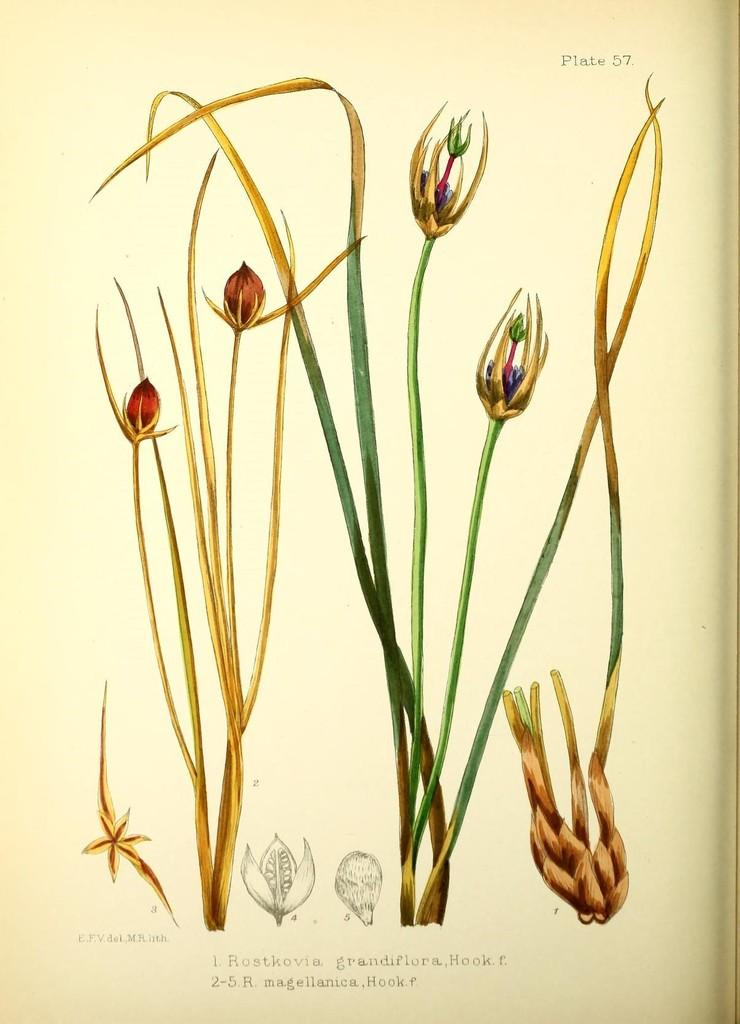What is the main subject of the image? The image contains a sketch of a poster. What type of plants are depicted in the image? There are plants with flowers and buds in the image. Where are parts of the plants located in the image? Parts of plants are visible at the bottom of the image. What can be read on the poster in the image? There is text written on the poster in the image. How many balloons are tied to the foot of the plant in the image? There are no balloons or feet present in the image; it features a sketch of a poster with plants and text. 